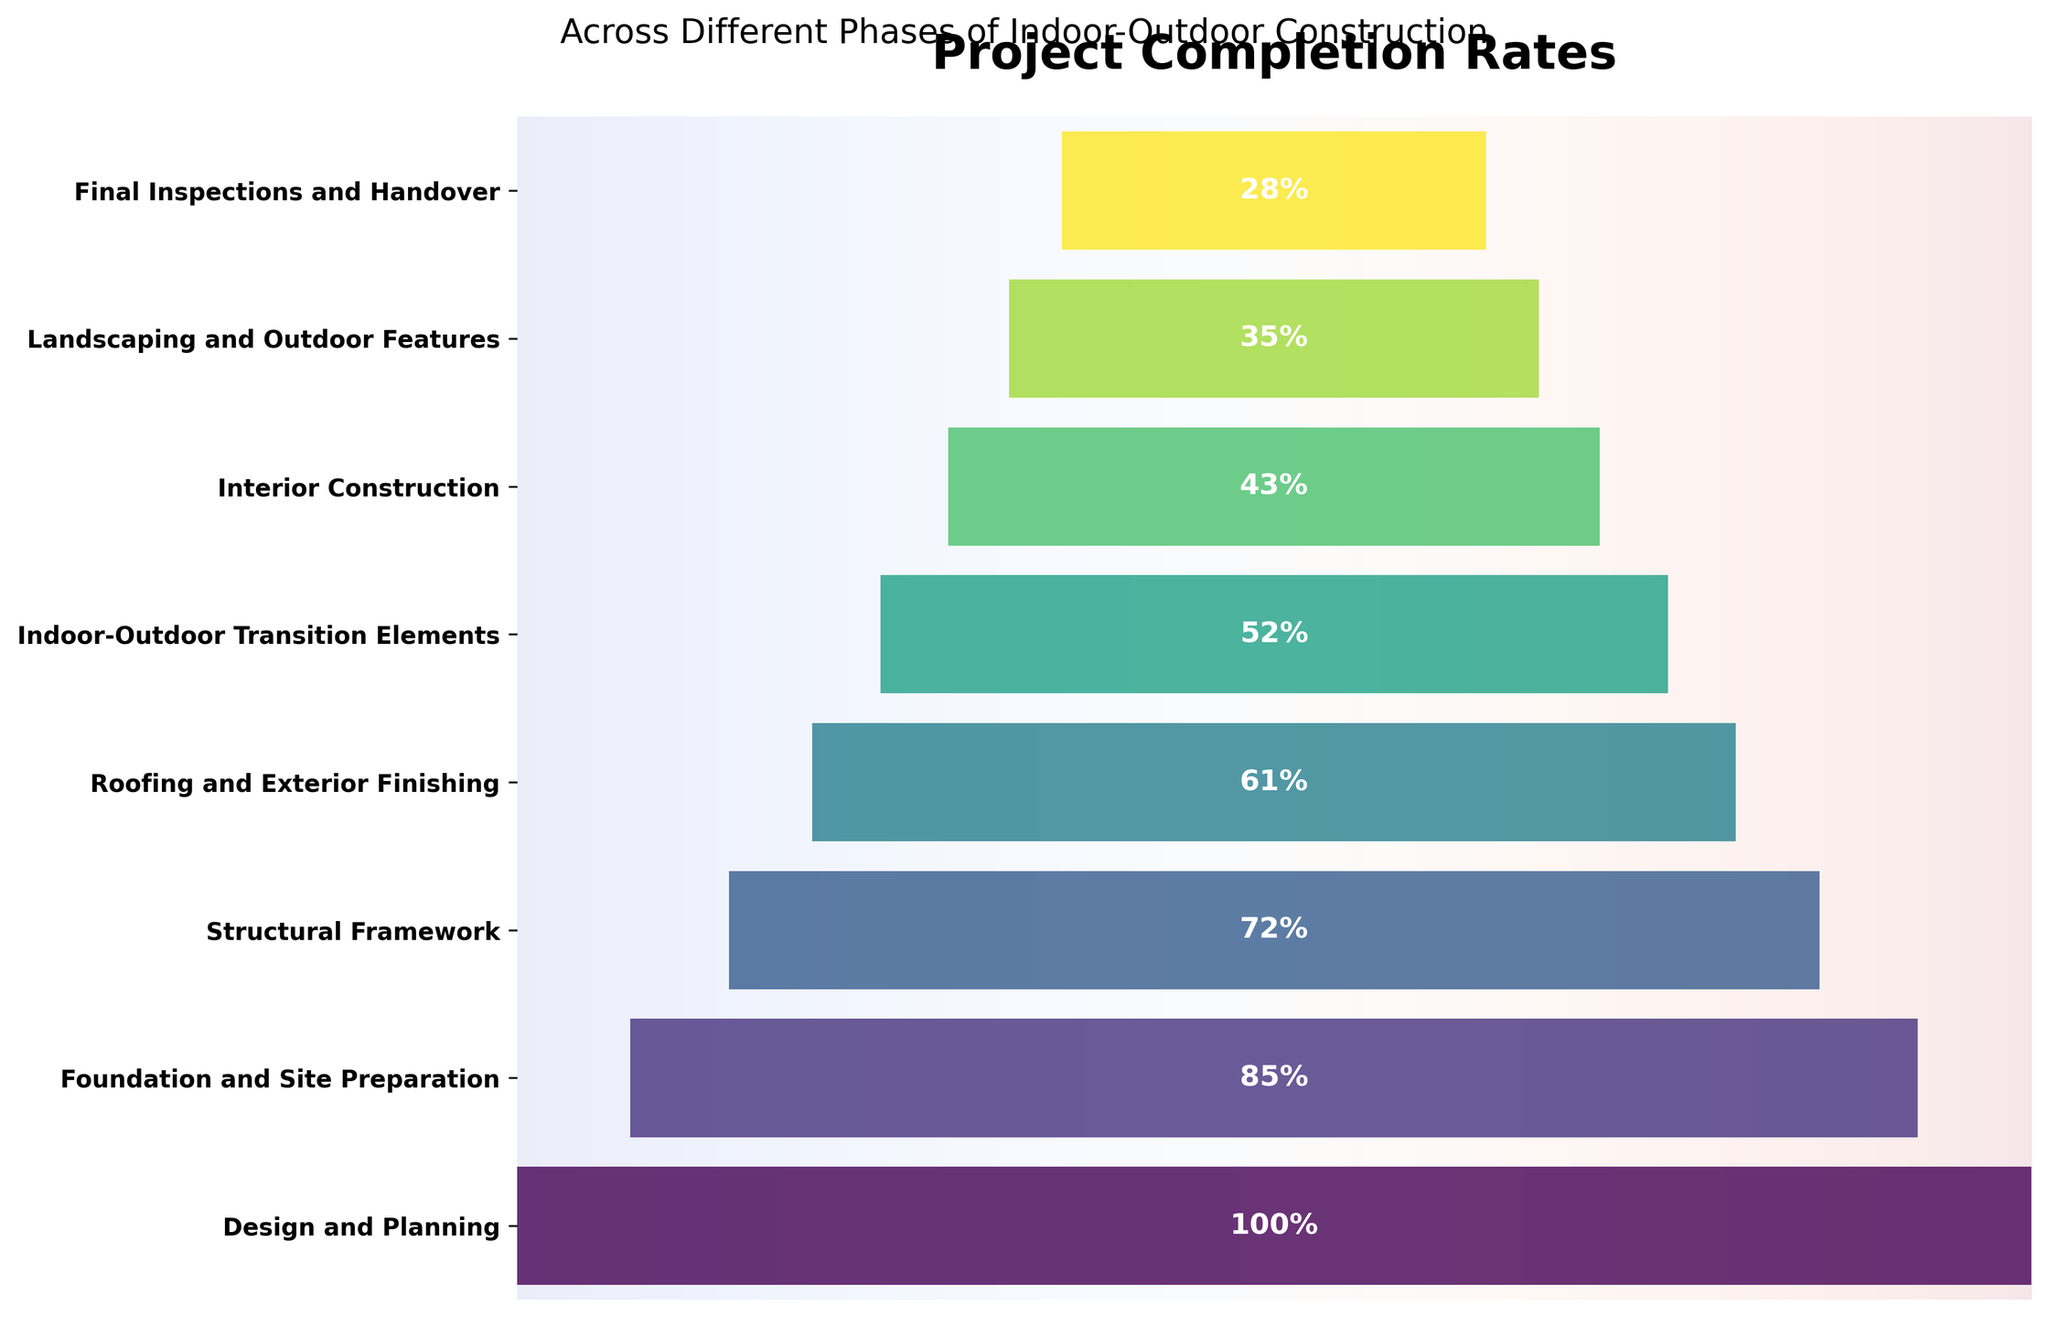What's the title of the chart? The title of the chart is found at the top and reads "Project Completion Rates."
Answer: Project Completion Rates What is the subtitle of the chart? The subtitle is located beneath the main title and reads "Across Different Phases of Indoor-Outdoor Construction."
Answer: Across Different Phases of Indoor-Outdoor Construction What are the phases listed on the y-axis? The phases are listed vertically on the y-axis from top to bottom. They are: Design and Planning, Foundation and Site Preparation, Structural Framework, Roofing and Exterior Finishing, Indoor-Outdoor Transition Elements, Interior Construction, Landscaping and Outdoor Features, and Final Inspections and Handover.
Answer: Design and Planning, Foundation and Site Preparation, Structural Framework, Roofing and Exterior Finishing, Indoor-Outdoor Transition Elements, Interior Construction, Landscaping and Outdoor Features, Final Inspections and Handover Which phase has the lowest completion rate? By looking at the chart, we can see that the "Final Inspections and Handover" phase has the smallest bar, indicating the lowest completion rate, which is found at 28%.
Answer: Final Inspections and Handover What is the difference in completion rates between the "Design and Planning" phase and the "Final Inspections and Handover" phase? The "Design and Planning" phase has a completion rate of 100%, and the "Final Inspections and Handover" phase has a completion rate of 28%. The difference is calculated as 100% - 28% = 72%.
Answer: 72% What is the combined completion rate of the "Structural Framework" and "Roofing and Exterior Finishing" phases? The completion rates for "Structural Framework" and "Roofing and Exterior Finishing" are 72% and 61% respectively. Adding them together gives 72% + 61% = 133%.
Answer: 133% Which two phases have the closest completion rates? By comparing the numerical labels on the bars, the "Structural Framework" phase at 72% and the "Roofing and Exterior Finishing" phase at 61% have a smaller difference compared to other pairs, specifically a difference of 11%.
Answer: Structural Framework and Roofing and Exterior Finishing How does the completion rate of "Landscaping and Outdoor Features" compare to that of "Interior Construction"? The completion rate for "Landscaping and Outdoor Features" is 35%, and for "Interior Construction" it is 43%. The rate for "Interior Construction" is higher than that of "Landscaping and Outdoor Features" by 8%.
Answer: Interior Construction is higher by 8% What's the average completion rate across all phases? To calculate the average completion rate, sum up all the completion rates and then divide by the number of phases: (100% + 85% + 72% + 61% + 52% + 43% + 35% + 28%) / 8 = 59.5%.
Answer: 59.5% What percentage of the total completion can be attributed to "Foundation and Site Preparation" and "Roofing and Exterior Finishing" phases combined? Summing the completion rates of "Foundation and Site Preparation" (85%) and "Roofing and Exterior Finishing" (61%) results in 85% + 61% = 146%. The combined completion rate for these phases is 146%.
Answer: 146% 